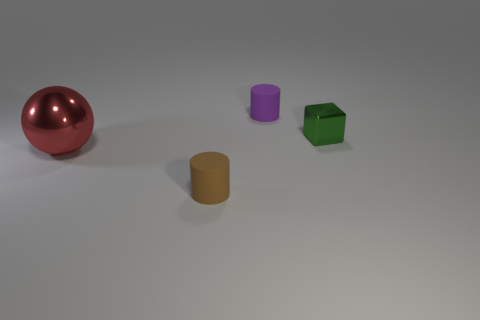How many balls are yellow matte things or big red metal things?
Keep it short and to the point. 1. Are there any other things that are the same shape as the small metallic thing?
Make the answer very short. No. Is the number of green objects behind the tiny green object greater than the number of tiny purple matte cylinders that are behind the purple matte cylinder?
Offer a terse response. No. There is a tiny rubber cylinder in front of the large red metallic sphere; what number of objects are left of it?
Ensure brevity in your answer.  1. What number of objects are small matte cylinders or big blue cylinders?
Your response must be concise. 2. Is the shape of the big metal thing the same as the small brown object?
Your answer should be very brief. No. What is the small brown cylinder made of?
Your answer should be compact. Rubber. How many objects are to the left of the small shiny object and to the right of the metal sphere?
Keep it short and to the point. 2. Is the size of the metallic block the same as the red ball?
Your answer should be very brief. No. Is the size of the matte cylinder that is behind the brown object the same as the red shiny ball?
Provide a short and direct response. No. 